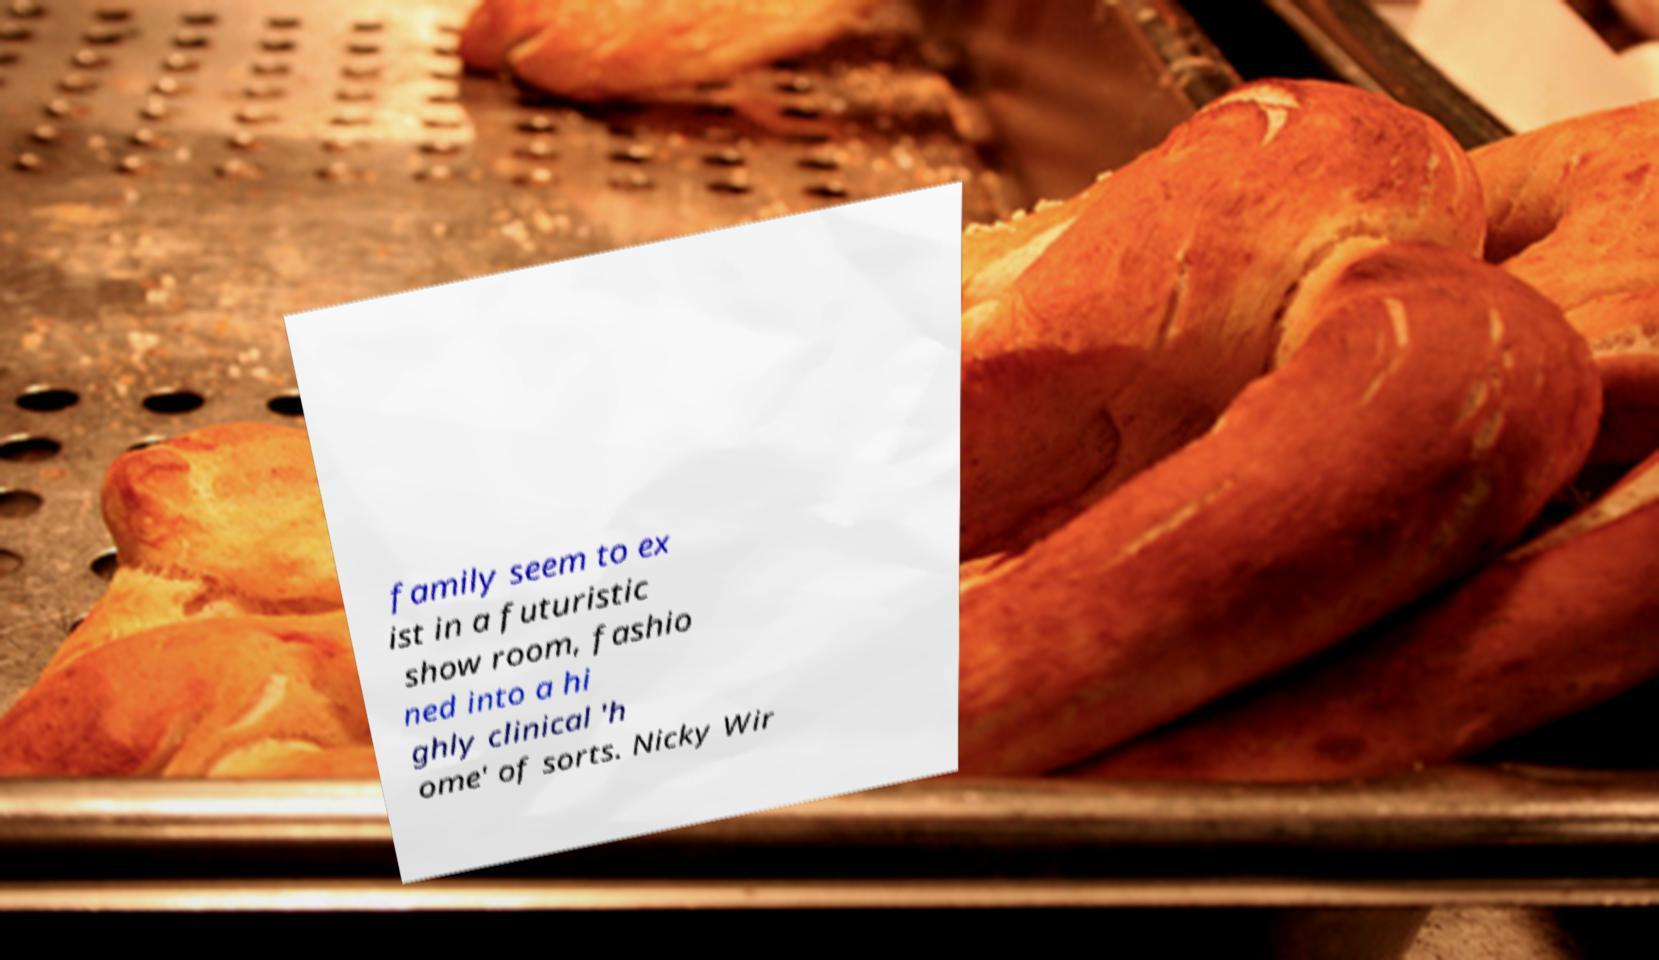Please identify and transcribe the text found in this image. family seem to ex ist in a futuristic show room, fashio ned into a hi ghly clinical 'h ome' of sorts. Nicky Wir 